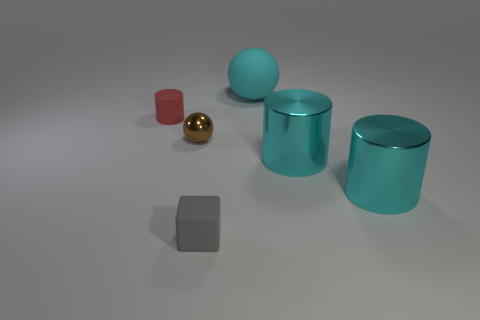Add 3 brown things. How many objects exist? 9 Subtract all spheres. How many objects are left? 4 Subtract 0 green cubes. How many objects are left? 6 Subtract all tiny gray cubes. Subtract all red cylinders. How many objects are left? 4 Add 2 brown things. How many brown things are left? 3 Add 2 big cylinders. How many big cylinders exist? 4 